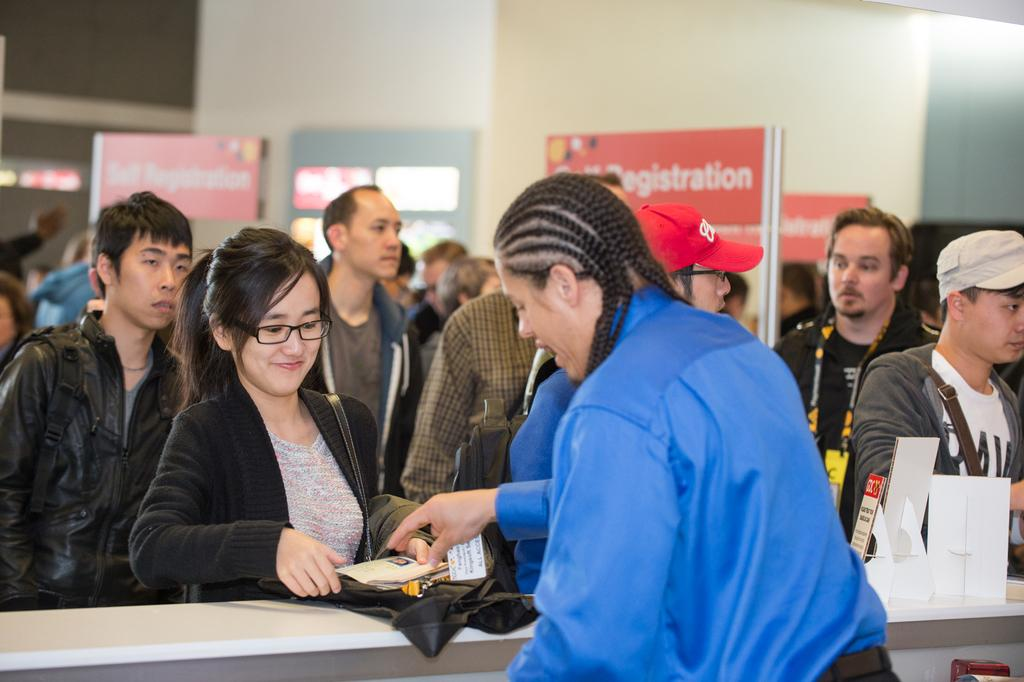What is the main subject of the image? The main subject of the image is a group of people. What can be seen in the background of the image? In the background of the image, there are name boards and a wall. How many beams are visible in the image? There are no beams visible in the image; the background features name boards and a wall. 